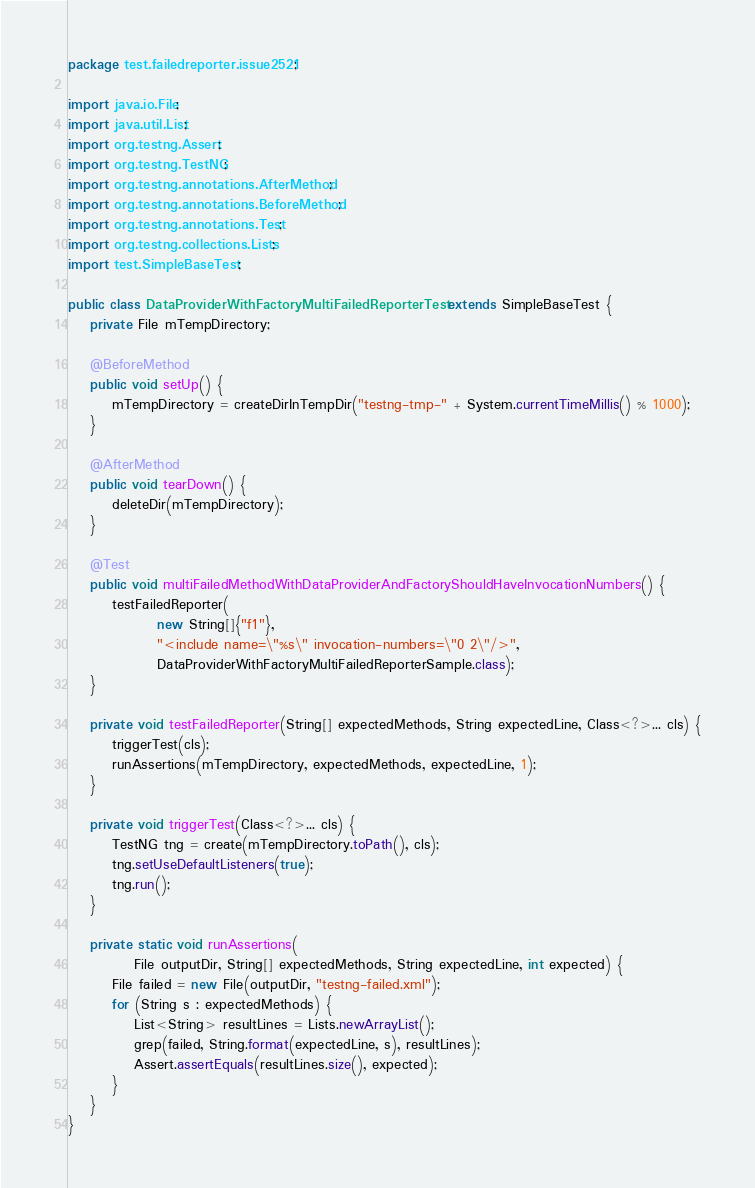Convert code to text. <code><loc_0><loc_0><loc_500><loc_500><_Java_>package test.failedreporter.issue2521;

import java.io.File;
import java.util.List;
import org.testng.Assert;
import org.testng.TestNG;
import org.testng.annotations.AfterMethod;
import org.testng.annotations.BeforeMethod;
import org.testng.annotations.Test;
import org.testng.collections.Lists;
import test.SimpleBaseTest;

public class DataProviderWithFactoryMultiFailedReporterTest extends SimpleBaseTest {
    private File mTempDirectory;

    @BeforeMethod
    public void setUp() {
        mTempDirectory = createDirInTempDir("testng-tmp-" + System.currentTimeMillis() % 1000);
    }

    @AfterMethod
    public void tearDown() {
        deleteDir(mTempDirectory);
    }

    @Test
    public void multiFailedMethodWithDataProviderAndFactoryShouldHaveInvocationNumbers() {
        testFailedReporter(
                new String[]{"f1"},
                "<include name=\"%s\" invocation-numbers=\"0 2\"/>",
                DataProviderWithFactoryMultiFailedReporterSample.class);
    }

    private void testFailedReporter(String[] expectedMethods, String expectedLine, Class<?>... cls) {
        triggerTest(cls);
        runAssertions(mTempDirectory, expectedMethods, expectedLine, 1);
    }

    private void triggerTest(Class<?>... cls) {
        TestNG tng = create(mTempDirectory.toPath(), cls);
        tng.setUseDefaultListeners(true);
        tng.run();
    }

    private static void runAssertions(
            File outputDir, String[] expectedMethods, String expectedLine, int expected) {
        File failed = new File(outputDir, "testng-failed.xml");
        for (String s : expectedMethods) {
            List<String> resultLines = Lists.newArrayList();
            grep(failed, String.format(expectedLine, s), resultLines);
            Assert.assertEquals(resultLines.size(), expected);
        }
    }
}
</code> 